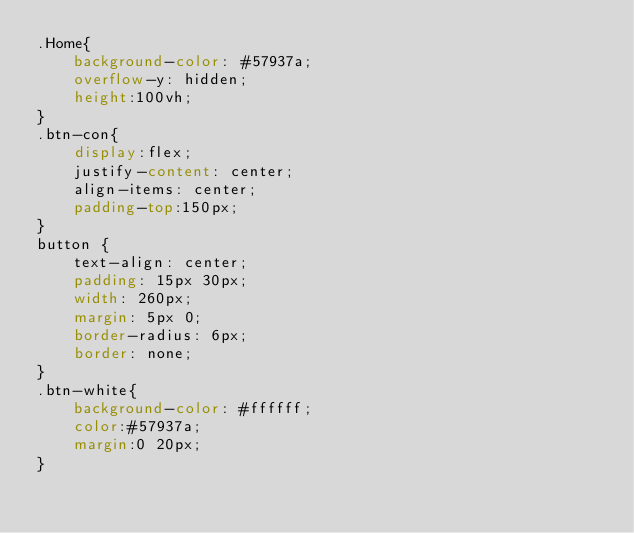Convert code to text. <code><loc_0><loc_0><loc_500><loc_500><_CSS_>.Home{
	background-color: #57937a;
	overflow-y: hidden;
	height:100vh;
}
.btn-con{
	display:flex;
	justify-content: center;
	align-items: center;
	padding-top:150px;
}
button {
	text-align: center;
	padding: 15px 30px;
	width: 260px;
	margin: 5px 0;
	border-radius: 6px;
	border: none;
}
.btn-white{
	background-color: #ffffff;
	color:#57937a;
	margin:0 20px;
}</code> 